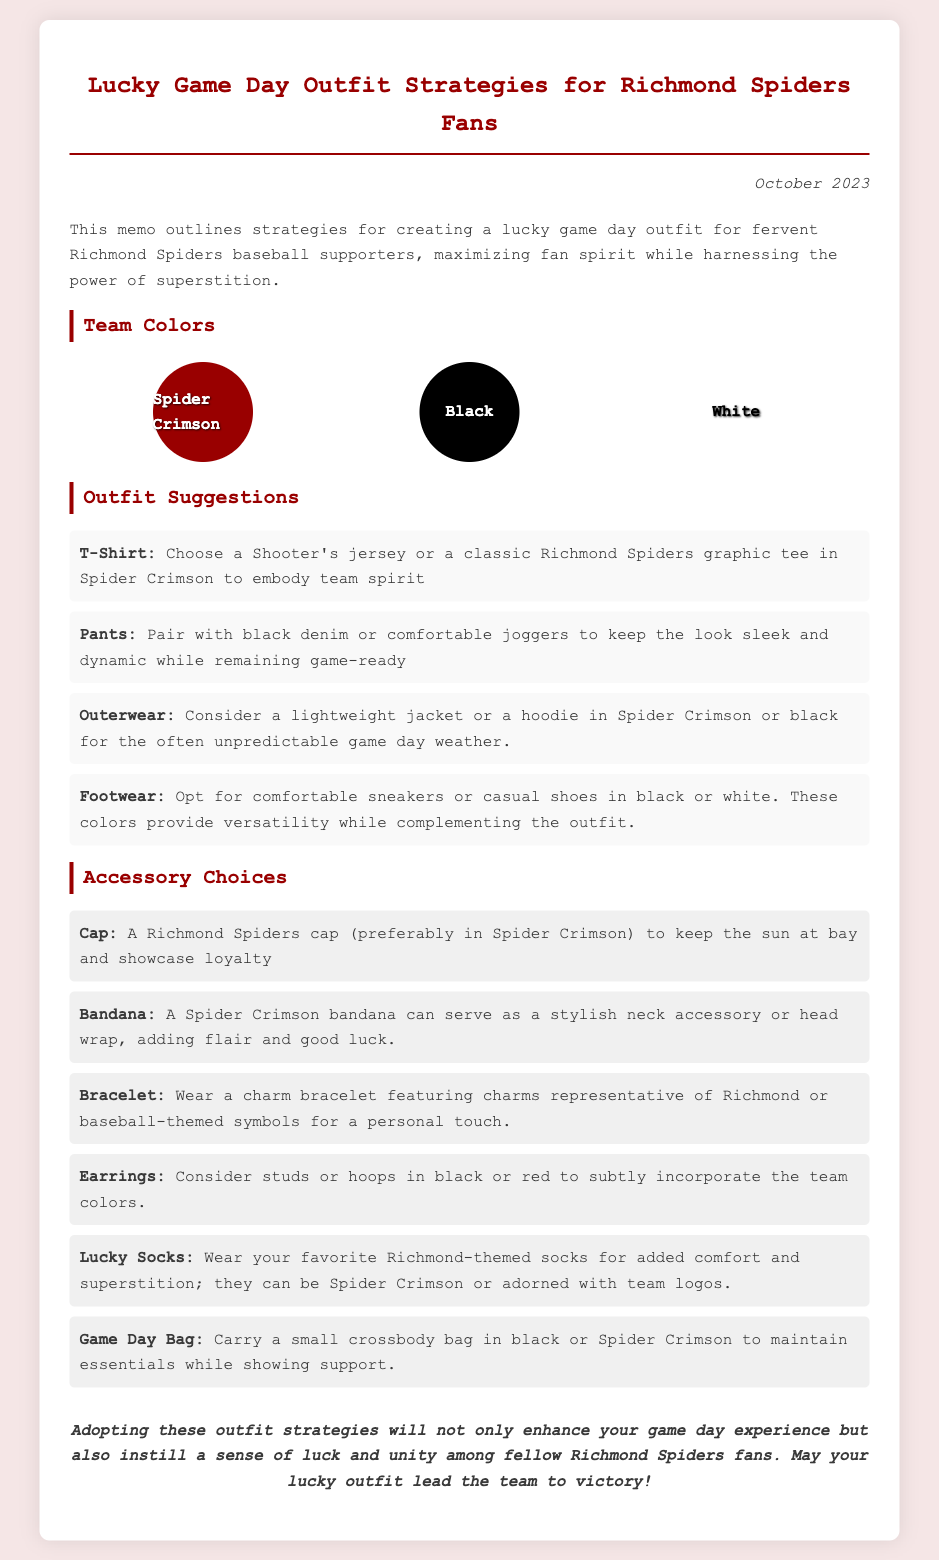What are the team colors? The team colors listed in the document are Spider Crimson, Black, and White.
Answer: Spider Crimson, Black, White What should be worn as outerwear? The document suggests considering a lightweight jacket or a hoodie in Spider Crimson or black for unpredictable game day weather.
Answer: Lightweight jacket or hoodie What type of footwear is recommended? The memo advises opting for comfortable sneakers or casual shoes in black or white for versatility.
Answer: Comfortable sneakers or casual shoes What accessory is suggested for sun protection? The document mentions wearing a Richmond Spiders cap (preferably in Spider Crimson) to keep the sun at bay.
Answer: Richmond Spiders cap How many accessory options are listed? The memo includes six accessory options for the lucky game day outfit.
Answer: Six What is the overall goal of the memo? The memo aims to outline strategies for creating a lucky game day outfit for fans to enhance their experience and support the team.
Answer: Enhance game day experience What color should the bandana be? The document recommends a Spider Crimson bandana as a stylish neck accessory or head wrap.
Answer: Spider Crimson What do the lucky socks feature? The lucky socks should be Richmond-themed and can be Spider Crimson or adorned with team logos.
Answer: Richmond-themed socks 